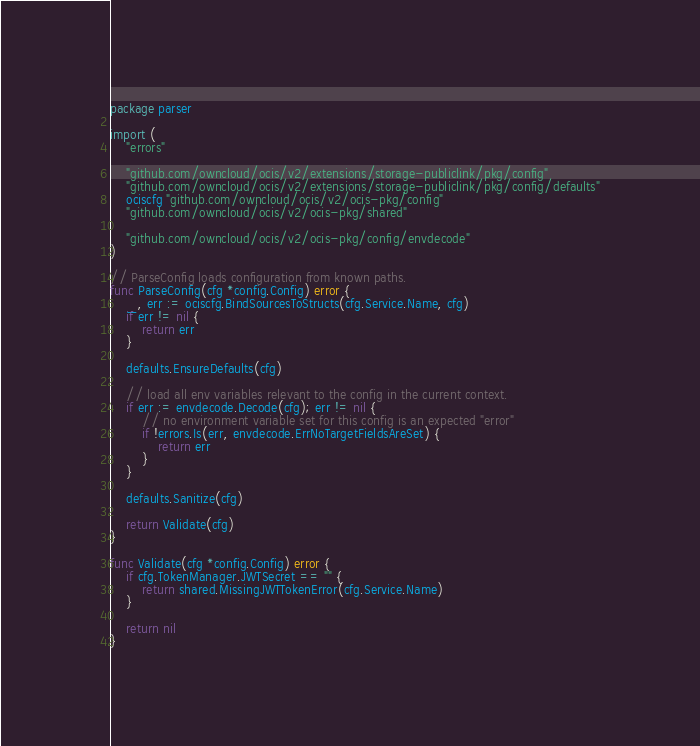<code> <loc_0><loc_0><loc_500><loc_500><_Go_>package parser

import (
	"errors"

	"github.com/owncloud/ocis/v2/extensions/storage-publiclink/pkg/config"
	"github.com/owncloud/ocis/v2/extensions/storage-publiclink/pkg/config/defaults"
	ociscfg "github.com/owncloud/ocis/v2/ocis-pkg/config"
	"github.com/owncloud/ocis/v2/ocis-pkg/shared"

	"github.com/owncloud/ocis/v2/ocis-pkg/config/envdecode"
)

// ParseConfig loads configuration from known paths.
func ParseConfig(cfg *config.Config) error {
	_, err := ociscfg.BindSourcesToStructs(cfg.Service.Name, cfg)
	if err != nil {
		return err
	}

	defaults.EnsureDefaults(cfg)

	// load all env variables relevant to the config in the current context.
	if err := envdecode.Decode(cfg); err != nil {
		// no environment variable set for this config is an expected "error"
		if !errors.Is(err, envdecode.ErrNoTargetFieldsAreSet) {
			return err
		}
	}

	defaults.Sanitize(cfg)

	return Validate(cfg)
}

func Validate(cfg *config.Config) error {
	if cfg.TokenManager.JWTSecret == "" {
		return shared.MissingJWTTokenError(cfg.Service.Name)
	}

	return nil
}
</code> 